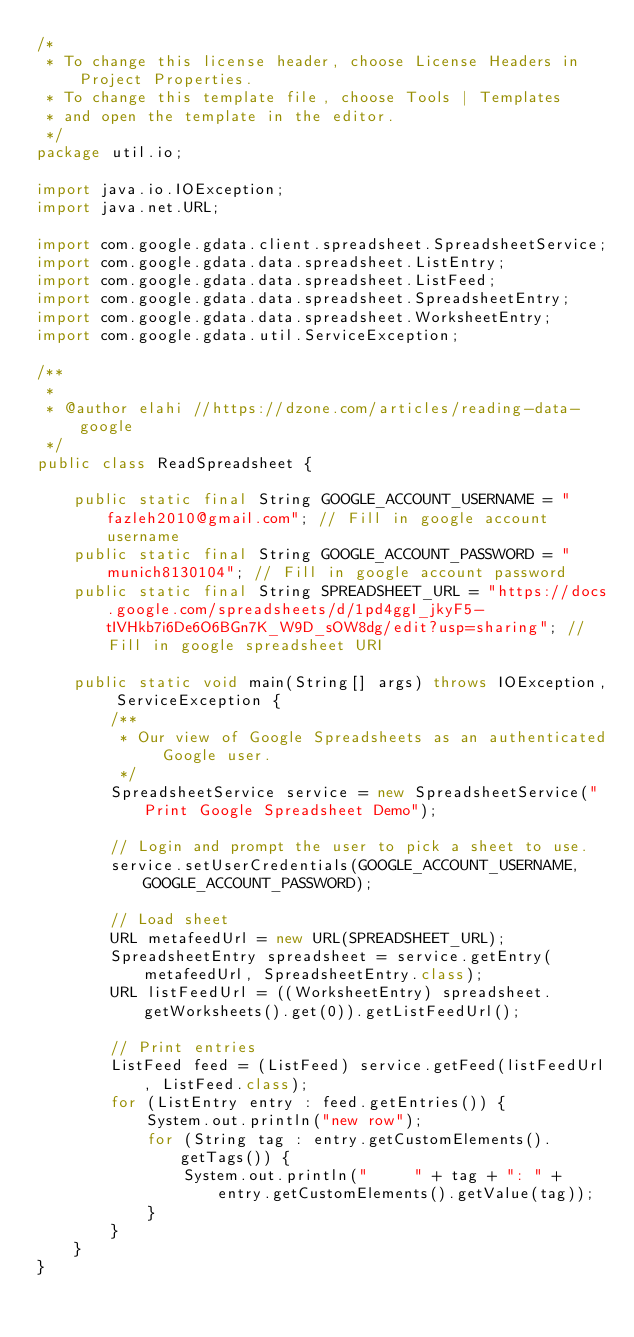<code> <loc_0><loc_0><loc_500><loc_500><_Java_>/*
 * To change this license header, choose License Headers in Project Properties.
 * To change this template file, choose Tools | Templates
 * and open the template in the editor.
 */
package util.io;

import java.io.IOException;
import java.net.URL;

import com.google.gdata.client.spreadsheet.SpreadsheetService;
import com.google.gdata.data.spreadsheet.ListEntry;
import com.google.gdata.data.spreadsheet.ListFeed;
import com.google.gdata.data.spreadsheet.SpreadsheetEntry;
import com.google.gdata.data.spreadsheet.WorksheetEntry;
import com.google.gdata.util.ServiceException;

/**
 *
 * @author elahi //https://dzone.com/articles/reading-data-google
 */
public class ReadSpreadsheet {

    public static final String GOOGLE_ACCOUNT_USERNAME = "fazleh2010@gmail.com"; // Fill in google account username
    public static final String GOOGLE_ACCOUNT_PASSWORD = "munich8130104"; // Fill in google account password
    public static final String SPREADSHEET_URL = "https://docs.google.com/spreadsheets/d/1pd4ggI_jkyF5-tIVHkb7i6De6O6BGn7K_W9D_sOW8dg/edit?usp=sharing"; //Fill in google spreadsheet URI

    public static void main(String[] args) throws IOException, ServiceException {
        /**
         * Our view of Google Spreadsheets as an authenticated Google user.
         */
        SpreadsheetService service = new SpreadsheetService("Print Google Spreadsheet Demo");

        // Login and prompt the user to pick a sheet to use.
        service.setUserCredentials(GOOGLE_ACCOUNT_USERNAME, GOOGLE_ACCOUNT_PASSWORD);

        // Load sheet
        URL metafeedUrl = new URL(SPREADSHEET_URL);
        SpreadsheetEntry spreadsheet = service.getEntry(metafeedUrl, SpreadsheetEntry.class);
        URL listFeedUrl = ((WorksheetEntry) spreadsheet.getWorksheets().get(0)).getListFeedUrl();

        // Print entries
        ListFeed feed = (ListFeed) service.getFeed(listFeedUrl, ListFeed.class);
        for (ListEntry entry : feed.getEntries()) {
            System.out.println("new row");
            for (String tag : entry.getCustomElements().getTags()) {
                System.out.println("     " + tag + ": " + entry.getCustomElements().getValue(tag));
            }
        }
    }
}
</code> 